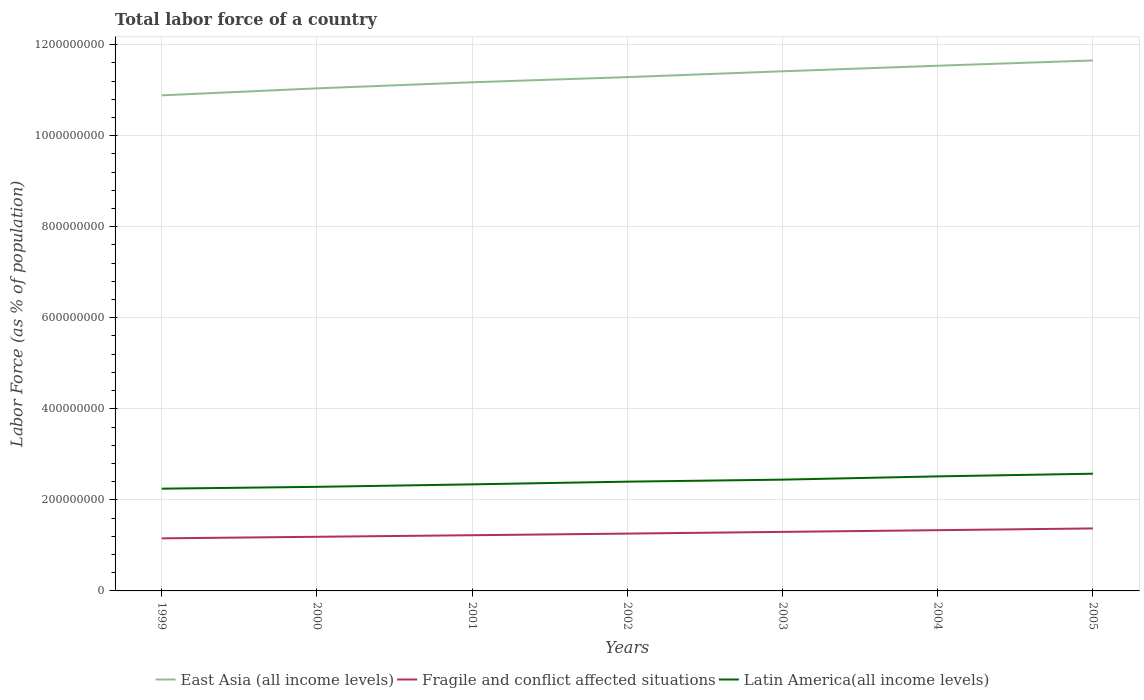Is the number of lines equal to the number of legend labels?
Give a very brief answer. Yes. Across all years, what is the maximum percentage of labor force in Latin America(all income levels)?
Offer a terse response. 2.25e+08. What is the total percentage of labor force in Fragile and conflict affected situations in the graph?
Keep it short and to the point. -3.82e+06. What is the difference between the highest and the second highest percentage of labor force in Latin America(all income levels)?
Offer a terse response. 3.29e+07. What is the difference between the highest and the lowest percentage of labor force in Fragile and conflict affected situations?
Your response must be concise. 3. How many lines are there?
Your response must be concise. 3. How many years are there in the graph?
Your answer should be very brief. 7. What is the difference between two consecutive major ticks on the Y-axis?
Give a very brief answer. 2.00e+08. Does the graph contain grids?
Offer a terse response. Yes. Where does the legend appear in the graph?
Give a very brief answer. Bottom center. How many legend labels are there?
Keep it short and to the point. 3. What is the title of the graph?
Your response must be concise. Total labor force of a country. Does "High income: nonOECD" appear as one of the legend labels in the graph?
Your answer should be very brief. No. What is the label or title of the X-axis?
Offer a very short reply. Years. What is the label or title of the Y-axis?
Give a very brief answer. Labor Force (as % of population). What is the Labor Force (as % of population) of East Asia (all income levels) in 1999?
Give a very brief answer. 1.09e+09. What is the Labor Force (as % of population) in Fragile and conflict affected situations in 1999?
Give a very brief answer. 1.15e+08. What is the Labor Force (as % of population) of Latin America(all income levels) in 1999?
Ensure brevity in your answer.  2.25e+08. What is the Labor Force (as % of population) in East Asia (all income levels) in 2000?
Provide a succinct answer. 1.10e+09. What is the Labor Force (as % of population) of Fragile and conflict affected situations in 2000?
Keep it short and to the point. 1.19e+08. What is the Labor Force (as % of population) of Latin America(all income levels) in 2000?
Offer a very short reply. 2.29e+08. What is the Labor Force (as % of population) in East Asia (all income levels) in 2001?
Offer a terse response. 1.12e+09. What is the Labor Force (as % of population) in Fragile and conflict affected situations in 2001?
Make the answer very short. 1.22e+08. What is the Labor Force (as % of population) of Latin America(all income levels) in 2001?
Make the answer very short. 2.34e+08. What is the Labor Force (as % of population) in East Asia (all income levels) in 2002?
Ensure brevity in your answer.  1.13e+09. What is the Labor Force (as % of population) of Fragile and conflict affected situations in 2002?
Provide a short and direct response. 1.26e+08. What is the Labor Force (as % of population) in Latin America(all income levels) in 2002?
Give a very brief answer. 2.40e+08. What is the Labor Force (as % of population) in East Asia (all income levels) in 2003?
Keep it short and to the point. 1.14e+09. What is the Labor Force (as % of population) of Fragile and conflict affected situations in 2003?
Provide a succinct answer. 1.30e+08. What is the Labor Force (as % of population) in Latin America(all income levels) in 2003?
Ensure brevity in your answer.  2.44e+08. What is the Labor Force (as % of population) of East Asia (all income levels) in 2004?
Provide a short and direct response. 1.15e+09. What is the Labor Force (as % of population) of Fragile and conflict affected situations in 2004?
Make the answer very short. 1.33e+08. What is the Labor Force (as % of population) in Latin America(all income levels) in 2004?
Your response must be concise. 2.52e+08. What is the Labor Force (as % of population) in East Asia (all income levels) in 2005?
Provide a succinct answer. 1.17e+09. What is the Labor Force (as % of population) of Fragile and conflict affected situations in 2005?
Make the answer very short. 1.37e+08. What is the Labor Force (as % of population) of Latin America(all income levels) in 2005?
Keep it short and to the point. 2.57e+08. Across all years, what is the maximum Labor Force (as % of population) in East Asia (all income levels)?
Give a very brief answer. 1.17e+09. Across all years, what is the maximum Labor Force (as % of population) in Fragile and conflict affected situations?
Your answer should be very brief. 1.37e+08. Across all years, what is the maximum Labor Force (as % of population) in Latin America(all income levels)?
Make the answer very short. 2.57e+08. Across all years, what is the minimum Labor Force (as % of population) of East Asia (all income levels)?
Your answer should be very brief. 1.09e+09. Across all years, what is the minimum Labor Force (as % of population) in Fragile and conflict affected situations?
Ensure brevity in your answer.  1.15e+08. Across all years, what is the minimum Labor Force (as % of population) in Latin America(all income levels)?
Your answer should be very brief. 2.25e+08. What is the total Labor Force (as % of population) in East Asia (all income levels) in the graph?
Your answer should be very brief. 7.90e+09. What is the total Labor Force (as % of population) of Fragile and conflict affected situations in the graph?
Offer a terse response. 8.83e+08. What is the total Labor Force (as % of population) in Latin America(all income levels) in the graph?
Your answer should be very brief. 1.68e+09. What is the difference between the Labor Force (as % of population) in East Asia (all income levels) in 1999 and that in 2000?
Provide a succinct answer. -1.53e+07. What is the difference between the Labor Force (as % of population) of Fragile and conflict affected situations in 1999 and that in 2000?
Offer a very short reply. -3.44e+06. What is the difference between the Labor Force (as % of population) in Latin America(all income levels) in 1999 and that in 2000?
Give a very brief answer. -4.02e+06. What is the difference between the Labor Force (as % of population) in East Asia (all income levels) in 1999 and that in 2001?
Keep it short and to the point. -2.87e+07. What is the difference between the Labor Force (as % of population) in Fragile and conflict affected situations in 1999 and that in 2001?
Offer a terse response. -6.85e+06. What is the difference between the Labor Force (as % of population) of Latin America(all income levels) in 1999 and that in 2001?
Your response must be concise. -9.49e+06. What is the difference between the Labor Force (as % of population) of East Asia (all income levels) in 1999 and that in 2002?
Give a very brief answer. -4.00e+07. What is the difference between the Labor Force (as % of population) in Fragile and conflict affected situations in 1999 and that in 2002?
Make the answer very short. -1.04e+07. What is the difference between the Labor Force (as % of population) of Latin America(all income levels) in 1999 and that in 2002?
Your answer should be very brief. -1.54e+07. What is the difference between the Labor Force (as % of population) of East Asia (all income levels) in 1999 and that in 2003?
Your answer should be very brief. -5.28e+07. What is the difference between the Labor Force (as % of population) in Fragile and conflict affected situations in 1999 and that in 2003?
Keep it short and to the point. -1.42e+07. What is the difference between the Labor Force (as % of population) of Latin America(all income levels) in 1999 and that in 2003?
Offer a very short reply. -1.99e+07. What is the difference between the Labor Force (as % of population) of East Asia (all income levels) in 1999 and that in 2004?
Give a very brief answer. -6.50e+07. What is the difference between the Labor Force (as % of population) of Fragile and conflict affected situations in 1999 and that in 2004?
Your answer should be very brief. -1.79e+07. What is the difference between the Labor Force (as % of population) in Latin America(all income levels) in 1999 and that in 2004?
Make the answer very short. -2.70e+07. What is the difference between the Labor Force (as % of population) in East Asia (all income levels) in 1999 and that in 2005?
Your answer should be very brief. -7.66e+07. What is the difference between the Labor Force (as % of population) in Fragile and conflict affected situations in 1999 and that in 2005?
Your answer should be very brief. -2.18e+07. What is the difference between the Labor Force (as % of population) of Latin America(all income levels) in 1999 and that in 2005?
Make the answer very short. -3.29e+07. What is the difference between the Labor Force (as % of population) of East Asia (all income levels) in 2000 and that in 2001?
Provide a succinct answer. -1.34e+07. What is the difference between the Labor Force (as % of population) of Fragile and conflict affected situations in 2000 and that in 2001?
Ensure brevity in your answer.  -3.41e+06. What is the difference between the Labor Force (as % of population) of Latin America(all income levels) in 2000 and that in 2001?
Ensure brevity in your answer.  -5.47e+06. What is the difference between the Labor Force (as % of population) in East Asia (all income levels) in 2000 and that in 2002?
Offer a terse response. -2.47e+07. What is the difference between the Labor Force (as % of population) in Fragile and conflict affected situations in 2000 and that in 2002?
Offer a very short reply. -7.00e+06. What is the difference between the Labor Force (as % of population) in Latin America(all income levels) in 2000 and that in 2002?
Keep it short and to the point. -1.14e+07. What is the difference between the Labor Force (as % of population) in East Asia (all income levels) in 2000 and that in 2003?
Give a very brief answer. -3.76e+07. What is the difference between the Labor Force (as % of population) in Fragile and conflict affected situations in 2000 and that in 2003?
Ensure brevity in your answer.  -1.07e+07. What is the difference between the Labor Force (as % of population) in Latin America(all income levels) in 2000 and that in 2003?
Provide a short and direct response. -1.58e+07. What is the difference between the Labor Force (as % of population) in East Asia (all income levels) in 2000 and that in 2004?
Keep it short and to the point. -4.98e+07. What is the difference between the Labor Force (as % of population) in Fragile and conflict affected situations in 2000 and that in 2004?
Provide a short and direct response. -1.45e+07. What is the difference between the Labor Force (as % of population) in Latin America(all income levels) in 2000 and that in 2004?
Offer a very short reply. -2.30e+07. What is the difference between the Labor Force (as % of population) in East Asia (all income levels) in 2000 and that in 2005?
Offer a terse response. -6.13e+07. What is the difference between the Labor Force (as % of population) of Fragile and conflict affected situations in 2000 and that in 2005?
Your response must be concise. -1.83e+07. What is the difference between the Labor Force (as % of population) of Latin America(all income levels) in 2000 and that in 2005?
Your answer should be compact. -2.89e+07. What is the difference between the Labor Force (as % of population) in East Asia (all income levels) in 2001 and that in 2002?
Your response must be concise. -1.14e+07. What is the difference between the Labor Force (as % of population) in Fragile and conflict affected situations in 2001 and that in 2002?
Your answer should be compact. -3.59e+06. What is the difference between the Labor Force (as % of population) in Latin America(all income levels) in 2001 and that in 2002?
Offer a very short reply. -5.95e+06. What is the difference between the Labor Force (as % of population) in East Asia (all income levels) in 2001 and that in 2003?
Give a very brief answer. -2.42e+07. What is the difference between the Labor Force (as % of population) in Fragile and conflict affected situations in 2001 and that in 2003?
Provide a short and direct response. -7.33e+06. What is the difference between the Labor Force (as % of population) of Latin America(all income levels) in 2001 and that in 2003?
Offer a very short reply. -1.04e+07. What is the difference between the Labor Force (as % of population) of East Asia (all income levels) in 2001 and that in 2004?
Your response must be concise. -3.64e+07. What is the difference between the Labor Force (as % of population) in Fragile and conflict affected situations in 2001 and that in 2004?
Make the answer very short. -1.11e+07. What is the difference between the Labor Force (as % of population) of Latin America(all income levels) in 2001 and that in 2004?
Provide a short and direct response. -1.76e+07. What is the difference between the Labor Force (as % of population) of East Asia (all income levels) in 2001 and that in 2005?
Your response must be concise. -4.79e+07. What is the difference between the Labor Force (as % of population) in Fragile and conflict affected situations in 2001 and that in 2005?
Provide a succinct answer. -1.49e+07. What is the difference between the Labor Force (as % of population) in Latin America(all income levels) in 2001 and that in 2005?
Your answer should be compact. -2.34e+07. What is the difference between the Labor Force (as % of population) of East Asia (all income levels) in 2002 and that in 2003?
Offer a very short reply. -1.28e+07. What is the difference between the Labor Force (as % of population) of Fragile and conflict affected situations in 2002 and that in 2003?
Give a very brief answer. -3.74e+06. What is the difference between the Labor Force (as % of population) in Latin America(all income levels) in 2002 and that in 2003?
Offer a terse response. -4.43e+06. What is the difference between the Labor Force (as % of population) of East Asia (all income levels) in 2002 and that in 2004?
Your answer should be very brief. -2.50e+07. What is the difference between the Labor Force (as % of population) in Fragile and conflict affected situations in 2002 and that in 2004?
Give a very brief answer. -7.50e+06. What is the difference between the Labor Force (as % of population) in Latin America(all income levels) in 2002 and that in 2004?
Offer a very short reply. -1.16e+07. What is the difference between the Labor Force (as % of population) of East Asia (all income levels) in 2002 and that in 2005?
Give a very brief answer. -3.66e+07. What is the difference between the Labor Force (as % of population) of Fragile and conflict affected situations in 2002 and that in 2005?
Your response must be concise. -1.13e+07. What is the difference between the Labor Force (as % of population) of Latin America(all income levels) in 2002 and that in 2005?
Make the answer very short. -1.75e+07. What is the difference between the Labor Force (as % of population) of East Asia (all income levels) in 2003 and that in 2004?
Provide a short and direct response. -1.22e+07. What is the difference between the Labor Force (as % of population) in Fragile and conflict affected situations in 2003 and that in 2004?
Your answer should be compact. -3.76e+06. What is the difference between the Labor Force (as % of population) of Latin America(all income levels) in 2003 and that in 2004?
Your answer should be compact. -7.18e+06. What is the difference between the Labor Force (as % of population) in East Asia (all income levels) in 2003 and that in 2005?
Your answer should be very brief. -2.37e+07. What is the difference between the Labor Force (as % of population) of Fragile and conflict affected situations in 2003 and that in 2005?
Your answer should be very brief. -7.58e+06. What is the difference between the Labor Force (as % of population) in Latin America(all income levels) in 2003 and that in 2005?
Your response must be concise. -1.30e+07. What is the difference between the Labor Force (as % of population) of East Asia (all income levels) in 2004 and that in 2005?
Provide a short and direct response. -1.15e+07. What is the difference between the Labor Force (as % of population) of Fragile and conflict affected situations in 2004 and that in 2005?
Your response must be concise. -3.82e+06. What is the difference between the Labor Force (as % of population) of Latin America(all income levels) in 2004 and that in 2005?
Make the answer very short. -5.86e+06. What is the difference between the Labor Force (as % of population) in East Asia (all income levels) in 1999 and the Labor Force (as % of population) in Fragile and conflict affected situations in 2000?
Provide a succinct answer. 9.70e+08. What is the difference between the Labor Force (as % of population) of East Asia (all income levels) in 1999 and the Labor Force (as % of population) of Latin America(all income levels) in 2000?
Offer a terse response. 8.60e+08. What is the difference between the Labor Force (as % of population) in Fragile and conflict affected situations in 1999 and the Labor Force (as % of population) in Latin America(all income levels) in 2000?
Your answer should be very brief. -1.13e+08. What is the difference between the Labor Force (as % of population) in East Asia (all income levels) in 1999 and the Labor Force (as % of population) in Fragile and conflict affected situations in 2001?
Keep it short and to the point. 9.66e+08. What is the difference between the Labor Force (as % of population) of East Asia (all income levels) in 1999 and the Labor Force (as % of population) of Latin America(all income levels) in 2001?
Your answer should be compact. 8.54e+08. What is the difference between the Labor Force (as % of population) of Fragile and conflict affected situations in 1999 and the Labor Force (as % of population) of Latin America(all income levels) in 2001?
Your answer should be very brief. -1.19e+08. What is the difference between the Labor Force (as % of population) of East Asia (all income levels) in 1999 and the Labor Force (as % of population) of Fragile and conflict affected situations in 2002?
Make the answer very short. 9.63e+08. What is the difference between the Labor Force (as % of population) in East Asia (all income levels) in 1999 and the Labor Force (as % of population) in Latin America(all income levels) in 2002?
Ensure brevity in your answer.  8.49e+08. What is the difference between the Labor Force (as % of population) of Fragile and conflict affected situations in 1999 and the Labor Force (as % of population) of Latin America(all income levels) in 2002?
Provide a succinct answer. -1.25e+08. What is the difference between the Labor Force (as % of population) in East Asia (all income levels) in 1999 and the Labor Force (as % of population) in Fragile and conflict affected situations in 2003?
Provide a succinct answer. 9.59e+08. What is the difference between the Labor Force (as % of population) of East Asia (all income levels) in 1999 and the Labor Force (as % of population) of Latin America(all income levels) in 2003?
Offer a very short reply. 8.44e+08. What is the difference between the Labor Force (as % of population) of Fragile and conflict affected situations in 1999 and the Labor Force (as % of population) of Latin America(all income levels) in 2003?
Ensure brevity in your answer.  -1.29e+08. What is the difference between the Labor Force (as % of population) of East Asia (all income levels) in 1999 and the Labor Force (as % of population) of Fragile and conflict affected situations in 2004?
Your answer should be very brief. 9.55e+08. What is the difference between the Labor Force (as % of population) in East Asia (all income levels) in 1999 and the Labor Force (as % of population) in Latin America(all income levels) in 2004?
Provide a short and direct response. 8.37e+08. What is the difference between the Labor Force (as % of population) of Fragile and conflict affected situations in 1999 and the Labor Force (as % of population) of Latin America(all income levels) in 2004?
Provide a short and direct response. -1.36e+08. What is the difference between the Labor Force (as % of population) in East Asia (all income levels) in 1999 and the Labor Force (as % of population) in Fragile and conflict affected situations in 2005?
Offer a very short reply. 9.51e+08. What is the difference between the Labor Force (as % of population) of East Asia (all income levels) in 1999 and the Labor Force (as % of population) of Latin America(all income levels) in 2005?
Offer a terse response. 8.31e+08. What is the difference between the Labor Force (as % of population) of Fragile and conflict affected situations in 1999 and the Labor Force (as % of population) of Latin America(all income levels) in 2005?
Ensure brevity in your answer.  -1.42e+08. What is the difference between the Labor Force (as % of population) in East Asia (all income levels) in 2000 and the Labor Force (as % of population) in Fragile and conflict affected situations in 2001?
Provide a short and direct response. 9.81e+08. What is the difference between the Labor Force (as % of population) of East Asia (all income levels) in 2000 and the Labor Force (as % of population) of Latin America(all income levels) in 2001?
Ensure brevity in your answer.  8.70e+08. What is the difference between the Labor Force (as % of population) of Fragile and conflict affected situations in 2000 and the Labor Force (as % of population) of Latin America(all income levels) in 2001?
Your response must be concise. -1.15e+08. What is the difference between the Labor Force (as % of population) of East Asia (all income levels) in 2000 and the Labor Force (as % of population) of Fragile and conflict affected situations in 2002?
Your answer should be very brief. 9.78e+08. What is the difference between the Labor Force (as % of population) in East Asia (all income levels) in 2000 and the Labor Force (as % of population) in Latin America(all income levels) in 2002?
Give a very brief answer. 8.64e+08. What is the difference between the Labor Force (as % of population) in Fragile and conflict affected situations in 2000 and the Labor Force (as % of population) in Latin America(all income levels) in 2002?
Provide a short and direct response. -1.21e+08. What is the difference between the Labor Force (as % of population) of East Asia (all income levels) in 2000 and the Labor Force (as % of population) of Fragile and conflict affected situations in 2003?
Keep it short and to the point. 9.74e+08. What is the difference between the Labor Force (as % of population) of East Asia (all income levels) in 2000 and the Labor Force (as % of population) of Latin America(all income levels) in 2003?
Offer a very short reply. 8.59e+08. What is the difference between the Labor Force (as % of population) of Fragile and conflict affected situations in 2000 and the Labor Force (as % of population) of Latin America(all income levels) in 2003?
Make the answer very short. -1.26e+08. What is the difference between the Labor Force (as % of population) in East Asia (all income levels) in 2000 and the Labor Force (as % of population) in Fragile and conflict affected situations in 2004?
Provide a succinct answer. 9.70e+08. What is the difference between the Labor Force (as % of population) in East Asia (all income levels) in 2000 and the Labor Force (as % of population) in Latin America(all income levels) in 2004?
Offer a terse response. 8.52e+08. What is the difference between the Labor Force (as % of population) in Fragile and conflict affected situations in 2000 and the Labor Force (as % of population) in Latin America(all income levels) in 2004?
Offer a terse response. -1.33e+08. What is the difference between the Labor Force (as % of population) of East Asia (all income levels) in 2000 and the Labor Force (as % of population) of Fragile and conflict affected situations in 2005?
Your answer should be very brief. 9.67e+08. What is the difference between the Labor Force (as % of population) of East Asia (all income levels) in 2000 and the Labor Force (as % of population) of Latin America(all income levels) in 2005?
Provide a succinct answer. 8.46e+08. What is the difference between the Labor Force (as % of population) of Fragile and conflict affected situations in 2000 and the Labor Force (as % of population) of Latin America(all income levels) in 2005?
Keep it short and to the point. -1.39e+08. What is the difference between the Labor Force (as % of population) of East Asia (all income levels) in 2001 and the Labor Force (as % of population) of Fragile and conflict affected situations in 2002?
Your response must be concise. 9.91e+08. What is the difference between the Labor Force (as % of population) of East Asia (all income levels) in 2001 and the Labor Force (as % of population) of Latin America(all income levels) in 2002?
Your answer should be very brief. 8.77e+08. What is the difference between the Labor Force (as % of population) of Fragile and conflict affected situations in 2001 and the Labor Force (as % of population) of Latin America(all income levels) in 2002?
Your answer should be very brief. -1.18e+08. What is the difference between the Labor Force (as % of population) in East Asia (all income levels) in 2001 and the Labor Force (as % of population) in Fragile and conflict affected situations in 2003?
Ensure brevity in your answer.  9.88e+08. What is the difference between the Labor Force (as % of population) of East Asia (all income levels) in 2001 and the Labor Force (as % of population) of Latin America(all income levels) in 2003?
Offer a very short reply. 8.73e+08. What is the difference between the Labor Force (as % of population) in Fragile and conflict affected situations in 2001 and the Labor Force (as % of population) in Latin America(all income levels) in 2003?
Offer a terse response. -1.22e+08. What is the difference between the Labor Force (as % of population) of East Asia (all income levels) in 2001 and the Labor Force (as % of population) of Fragile and conflict affected situations in 2004?
Your answer should be compact. 9.84e+08. What is the difference between the Labor Force (as % of population) in East Asia (all income levels) in 2001 and the Labor Force (as % of population) in Latin America(all income levels) in 2004?
Offer a very short reply. 8.66e+08. What is the difference between the Labor Force (as % of population) in Fragile and conflict affected situations in 2001 and the Labor Force (as % of population) in Latin America(all income levels) in 2004?
Provide a succinct answer. -1.29e+08. What is the difference between the Labor Force (as % of population) in East Asia (all income levels) in 2001 and the Labor Force (as % of population) in Fragile and conflict affected situations in 2005?
Ensure brevity in your answer.  9.80e+08. What is the difference between the Labor Force (as % of population) in East Asia (all income levels) in 2001 and the Labor Force (as % of population) in Latin America(all income levels) in 2005?
Your answer should be very brief. 8.60e+08. What is the difference between the Labor Force (as % of population) in Fragile and conflict affected situations in 2001 and the Labor Force (as % of population) in Latin America(all income levels) in 2005?
Provide a short and direct response. -1.35e+08. What is the difference between the Labor Force (as % of population) of East Asia (all income levels) in 2002 and the Labor Force (as % of population) of Fragile and conflict affected situations in 2003?
Give a very brief answer. 9.99e+08. What is the difference between the Labor Force (as % of population) of East Asia (all income levels) in 2002 and the Labor Force (as % of population) of Latin America(all income levels) in 2003?
Offer a terse response. 8.84e+08. What is the difference between the Labor Force (as % of population) of Fragile and conflict affected situations in 2002 and the Labor Force (as % of population) of Latin America(all income levels) in 2003?
Provide a succinct answer. -1.19e+08. What is the difference between the Labor Force (as % of population) of East Asia (all income levels) in 2002 and the Labor Force (as % of population) of Fragile and conflict affected situations in 2004?
Make the answer very short. 9.95e+08. What is the difference between the Labor Force (as % of population) of East Asia (all income levels) in 2002 and the Labor Force (as % of population) of Latin America(all income levels) in 2004?
Your answer should be very brief. 8.77e+08. What is the difference between the Labor Force (as % of population) of Fragile and conflict affected situations in 2002 and the Labor Force (as % of population) of Latin America(all income levels) in 2004?
Your response must be concise. -1.26e+08. What is the difference between the Labor Force (as % of population) in East Asia (all income levels) in 2002 and the Labor Force (as % of population) in Fragile and conflict affected situations in 2005?
Offer a very short reply. 9.91e+08. What is the difference between the Labor Force (as % of population) of East Asia (all income levels) in 2002 and the Labor Force (as % of population) of Latin America(all income levels) in 2005?
Offer a very short reply. 8.71e+08. What is the difference between the Labor Force (as % of population) of Fragile and conflict affected situations in 2002 and the Labor Force (as % of population) of Latin America(all income levels) in 2005?
Ensure brevity in your answer.  -1.32e+08. What is the difference between the Labor Force (as % of population) in East Asia (all income levels) in 2003 and the Labor Force (as % of population) in Fragile and conflict affected situations in 2004?
Provide a succinct answer. 1.01e+09. What is the difference between the Labor Force (as % of population) of East Asia (all income levels) in 2003 and the Labor Force (as % of population) of Latin America(all income levels) in 2004?
Your response must be concise. 8.90e+08. What is the difference between the Labor Force (as % of population) in Fragile and conflict affected situations in 2003 and the Labor Force (as % of population) in Latin America(all income levels) in 2004?
Provide a succinct answer. -1.22e+08. What is the difference between the Labor Force (as % of population) in East Asia (all income levels) in 2003 and the Labor Force (as % of population) in Fragile and conflict affected situations in 2005?
Keep it short and to the point. 1.00e+09. What is the difference between the Labor Force (as % of population) in East Asia (all income levels) in 2003 and the Labor Force (as % of population) in Latin America(all income levels) in 2005?
Provide a short and direct response. 8.84e+08. What is the difference between the Labor Force (as % of population) in Fragile and conflict affected situations in 2003 and the Labor Force (as % of population) in Latin America(all income levels) in 2005?
Your answer should be compact. -1.28e+08. What is the difference between the Labor Force (as % of population) of East Asia (all income levels) in 2004 and the Labor Force (as % of population) of Fragile and conflict affected situations in 2005?
Make the answer very short. 1.02e+09. What is the difference between the Labor Force (as % of population) in East Asia (all income levels) in 2004 and the Labor Force (as % of population) in Latin America(all income levels) in 2005?
Make the answer very short. 8.96e+08. What is the difference between the Labor Force (as % of population) of Fragile and conflict affected situations in 2004 and the Labor Force (as % of population) of Latin America(all income levels) in 2005?
Give a very brief answer. -1.24e+08. What is the average Labor Force (as % of population) of East Asia (all income levels) per year?
Offer a very short reply. 1.13e+09. What is the average Labor Force (as % of population) of Fragile and conflict affected situations per year?
Your response must be concise. 1.26e+08. What is the average Labor Force (as % of population) of Latin America(all income levels) per year?
Your response must be concise. 2.40e+08. In the year 1999, what is the difference between the Labor Force (as % of population) of East Asia (all income levels) and Labor Force (as % of population) of Fragile and conflict affected situations?
Give a very brief answer. 9.73e+08. In the year 1999, what is the difference between the Labor Force (as % of population) of East Asia (all income levels) and Labor Force (as % of population) of Latin America(all income levels)?
Your answer should be compact. 8.64e+08. In the year 1999, what is the difference between the Labor Force (as % of population) in Fragile and conflict affected situations and Labor Force (as % of population) in Latin America(all income levels)?
Your response must be concise. -1.09e+08. In the year 2000, what is the difference between the Labor Force (as % of population) of East Asia (all income levels) and Labor Force (as % of population) of Fragile and conflict affected situations?
Your answer should be very brief. 9.85e+08. In the year 2000, what is the difference between the Labor Force (as % of population) in East Asia (all income levels) and Labor Force (as % of population) in Latin America(all income levels)?
Make the answer very short. 8.75e+08. In the year 2000, what is the difference between the Labor Force (as % of population) in Fragile and conflict affected situations and Labor Force (as % of population) in Latin America(all income levels)?
Ensure brevity in your answer.  -1.10e+08. In the year 2001, what is the difference between the Labor Force (as % of population) of East Asia (all income levels) and Labor Force (as % of population) of Fragile and conflict affected situations?
Provide a succinct answer. 9.95e+08. In the year 2001, what is the difference between the Labor Force (as % of population) in East Asia (all income levels) and Labor Force (as % of population) in Latin America(all income levels)?
Keep it short and to the point. 8.83e+08. In the year 2001, what is the difference between the Labor Force (as % of population) of Fragile and conflict affected situations and Labor Force (as % of population) of Latin America(all income levels)?
Keep it short and to the point. -1.12e+08. In the year 2002, what is the difference between the Labor Force (as % of population) in East Asia (all income levels) and Labor Force (as % of population) in Fragile and conflict affected situations?
Your answer should be very brief. 1.00e+09. In the year 2002, what is the difference between the Labor Force (as % of population) in East Asia (all income levels) and Labor Force (as % of population) in Latin America(all income levels)?
Your response must be concise. 8.89e+08. In the year 2002, what is the difference between the Labor Force (as % of population) of Fragile and conflict affected situations and Labor Force (as % of population) of Latin America(all income levels)?
Make the answer very short. -1.14e+08. In the year 2003, what is the difference between the Labor Force (as % of population) of East Asia (all income levels) and Labor Force (as % of population) of Fragile and conflict affected situations?
Provide a succinct answer. 1.01e+09. In the year 2003, what is the difference between the Labor Force (as % of population) in East Asia (all income levels) and Labor Force (as % of population) in Latin America(all income levels)?
Keep it short and to the point. 8.97e+08. In the year 2003, what is the difference between the Labor Force (as % of population) in Fragile and conflict affected situations and Labor Force (as % of population) in Latin America(all income levels)?
Ensure brevity in your answer.  -1.15e+08. In the year 2004, what is the difference between the Labor Force (as % of population) in East Asia (all income levels) and Labor Force (as % of population) in Fragile and conflict affected situations?
Provide a succinct answer. 1.02e+09. In the year 2004, what is the difference between the Labor Force (as % of population) in East Asia (all income levels) and Labor Force (as % of population) in Latin America(all income levels)?
Offer a very short reply. 9.02e+08. In the year 2004, what is the difference between the Labor Force (as % of population) of Fragile and conflict affected situations and Labor Force (as % of population) of Latin America(all income levels)?
Give a very brief answer. -1.18e+08. In the year 2005, what is the difference between the Labor Force (as % of population) of East Asia (all income levels) and Labor Force (as % of population) of Fragile and conflict affected situations?
Ensure brevity in your answer.  1.03e+09. In the year 2005, what is the difference between the Labor Force (as % of population) of East Asia (all income levels) and Labor Force (as % of population) of Latin America(all income levels)?
Ensure brevity in your answer.  9.08e+08. In the year 2005, what is the difference between the Labor Force (as % of population) of Fragile and conflict affected situations and Labor Force (as % of population) of Latin America(all income levels)?
Provide a short and direct response. -1.20e+08. What is the ratio of the Labor Force (as % of population) of East Asia (all income levels) in 1999 to that in 2000?
Your answer should be compact. 0.99. What is the ratio of the Labor Force (as % of population) in Fragile and conflict affected situations in 1999 to that in 2000?
Your answer should be compact. 0.97. What is the ratio of the Labor Force (as % of population) of Latin America(all income levels) in 1999 to that in 2000?
Ensure brevity in your answer.  0.98. What is the ratio of the Labor Force (as % of population) in East Asia (all income levels) in 1999 to that in 2001?
Give a very brief answer. 0.97. What is the ratio of the Labor Force (as % of population) of Fragile and conflict affected situations in 1999 to that in 2001?
Keep it short and to the point. 0.94. What is the ratio of the Labor Force (as % of population) in Latin America(all income levels) in 1999 to that in 2001?
Ensure brevity in your answer.  0.96. What is the ratio of the Labor Force (as % of population) of East Asia (all income levels) in 1999 to that in 2002?
Make the answer very short. 0.96. What is the ratio of the Labor Force (as % of population) of Fragile and conflict affected situations in 1999 to that in 2002?
Keep it short and to the point. 0.92. What is the ratio of the Labor Force (as % of population) in Latin America(all income levels) in 1999 to that in 2002?
Ensure brevity in your answer.  0.94. What is the ratio of the Labor Force (as % of population) in East Asia (all income levels) in 1999 to that in 2003?
Offer a terse response. 0.95. What is the ratio of the Labor Force (as % of population) in Fragile and conflict affected situations in 1999 to that in 2003?
Your response must be concise. 0.89. What is the ratio of the Labor Force (as % of population) of Latin America(all income levels) in 1999 to that in 2003?
Give a very brief answer. 0.92. What is the ratio of the Labor Force (as % of population) of East Asia (all income levels) in 1999 to that in 2004?
Your answer should be compact. 0.94. What is the ratio of the Labor Force (as % of population) in Fragile and conflict affected situations in 1999 to that in 2004?
Ensure brevity in your answer.  0.87. What is the ratio of the Labor Force (as % of population) in Latin America(all income levels) in 1999 to that in 2004?
Your answer should be very brief. 0.89. What is the ratio of the Labor Force (as % of population) of East Asia (all income levels) in 1999 to that in 2005?
Offer a very short reply. 0.93. What is the ratio of the Labor Force (as % of population) of Fragile and conflict affected situations in 1999 to that in 2005?
Ensure brevity in your answer.  0.84. What is the ratio of the Labor Force (as % of population) of Latin America(all income levels) in 1999 to that in 2005?
Provide a short and direct response. 0.87. What is the ratio of the Labor Force (as % of population) in East Asia (all income levels) in 2000 to that in 2001?
Your response must be concise. 0.99. What is the ratio of the Labor Force (as % of population) of Fragile and conflict affected situations in 2000 to that in 2001?
Provide a short and direct response. 0.97. What is the ratio of the Labor Force (as % of population) of Latin America(all income levels) in 2000 to that in 2001?
Make the answer very short. 0.98. What is the ratio of the Labor Force (as % of population) in East Asia (all income levels) in 2000 to that in 2002?
Offer a very short reply. 0.98. What is the ratio of the Labor Force (as % of population) of Latin America(all income levels) in 2000 to that in 2002?
Provide a short and direct response. 0.95. What is the ratio of the Labor Force (as % of population) in East Asia (all income levels) in 2000 to that in 2003?
Your answer should be very brief. 0.97. What is the ratio of the Labor Force (as % of population) of Fragile and conflict affected situations in 2000 to that in 2003?
Offer a very short reply. 0.92. What is the ratio of the Labor Force (as % of population) of Latin America(all income levels) in 2000 to that in 2003?
Provide a short and direct response. 0.94. What is the ratio of the Labor Force (as % of population) in East Asia (all income levels) in 2000 to that in 2004?
Keep it short and to the point. 0.96. What is the ratio of the Labor Force (as % of population) of Fragile and conflict affected situations in 2000 to that in 2004?
Your answer should be very brief. 0.89. What is the ratio of the Labor Force (as % of population) in Latin America(all income levels) in 2000 to that in 2004?
Offer a very short reply. 0.91. What is the ratio of the Labor Force (as % of population) in Fragile and conflict affected situations in 2000 to that in 2005?
Ensure brevity in your answer.  0.87. What is the ratio of the Labor Force (as % of population) of Latin America(all income levels) in 2000 to that in 2005?
Your response must be concise. 0.89. What is the ratio of the Labor Force (as % of population) of East Asia (all income levels) in 2001 to that in 2002?
Ensure brevity in your answer.  0.99. What is the ratio of the Labor Force (as % of population) of Fragile and conflict affected situations in 2001 to that in 2002?
Your answer should be compact. 0.97. What is the ratio of the Labor Force (as % of population) in Latin America(all income levels) in 2001 to that in 2002?
Offer a terse response. 0.98. What is the ratio of the Labor Force (as % of population) in East Asia (all income levels) in 2001 to that in 2003?
Offer a very short reply. 0.98. What is the ratio of the Labor Force (as % of population) in Fragile and conflict affected situations in 2001 to that in 2003?
Offer a very short reply. 0.94. What is the ratio of the Labor Force (as % of population) in Latin America(all income levels) in 2001 to that in 2003?
Keep it short and to the point. 0.96. What is the ratio of the Labor Force (as % of population) in East Asia (all income levels) in 2001 to that in 2004?
Your response must be concise. 0.97. What is the ratio of the Labor Force (as % of population) in Fragile and conflict affected situations in 2001 to that in 2004?
Your answer should be compact. 0.92. What is the ratio of the Labor Force (as % of population) of Latin America(all income levels) in 2001 to that in 2004?
Provide a short and direct response. 0.93. What is the ratio of the Labor Force (as % of population) of East Asia (all income levels) in 2001 to that in 2005?
Ensure brevity in your answer.  0.96. What is the ratio of the Labor Force (as % of population) in Fragile and conflict affected situations in 2001 to that in 2005?
Your answer should be very brief. 0.89. What is the ratio of the Labor Force (as % of population) of Fragile and conflict affected situations in 2002 to that in 2003?
Ensure brevity in your answer.  0.97. What is the ratio of the Labor Force (as % of population) in Latin America(all income levels) in 2002 to that in 2003?
Offer a very short reply. 0.98. What is the ratio of the Labor Force (as % of population) of East Asia (all income levels) in 2002 to that in 2004?
Offer a very short reply. 0.98. What is the ratio of the Labor Force (as % of population) in Fragile and conflict affected situations in 2002 to that in 2004?
Ensure brevity in your answer.  0.94. What is the ratio of the Labor Force (as % of population) of Latin America(all income levels) in 2002 to that in 2004?
Make the answer very short. 0.95. What is the ratio of the Labor Force (as % of population) in East Asia (all income levels) in 2002 to that in 2005?
Provide a short and direct response. 0.97. What is the ratio of the Labor Force (as % of population) in Fragile and conflict affected situations in 2002 to that in 2005?
Your answer should be very brief. 0.92. What is the ratio of the Labor Force (as % of population) of Latin America(all income levels) in 2002 to that in 2005?
Offer a very short reply. 0.93. What is the ratio of the Labor Force (as % of population) of Fragile and conflict affected situations in 2003 to that in 2004?
Ensure brevity in your answer.  0.97. What is the ratio of the Labor Force (as % of population) in Latin America(all income levels) in 2003 to that in 2004?
Make the answer very short. 0.97. What is the ratio of the Labor Force (as % of population) in East Asia (all income levels) in 2003 to that in 2005?
Your response must be concise. 0.98. What is the ratio of the Labor Force (as % of population) in Fragile and conflict affected situations in 2003 to that in 2005?
Provide a succinct answer. 0.94. What is the ratio of the Labor Force (as % of population) of Latin America(all income levels) in 2003 to that in 2005?
Make the answer very short. 0.95. What is the ratio of the Labor Force (as % of population) of Fragile and conflict affected situations in 2004 to that in 2005?
Offer a very short reply. 0.97. What is the ratio of the Labor Force (as % of population) of Latin America(all income levels) in 2004 to that in 2005?
Make the answer very short. 0.98. What is the difference between the highest and the second highest Labor Force (as % of population) of East Asia (all income levels)?
Your answer should be very brief. 1.15e+07. What is the difference between the highest and the second highest Labor Force (as % of population) in Fragile and conflict affected situations?
Your answer should be compact. 3.82e+06. What is the difference between the highest and the second highest Labor Force (as % of population) in Latin America(all income levels)?
Keep it short and to the point. 5.86e+06. What is the difference between the highest and the lowest Labor Force (as % of population) of East Asia (all income levels)?
Provide a short and direct response. 7.66e+07. What is the difference between the highest and the lowest Labor Force (as % of population) of Fragile and conflict affected situations?
Provide a short and direct response. 2.18e+07. What is the difference between the highest and the lowest Labor Force (as % of population) of Latin America(all income levels)?
Your answer should be compact. 3.29e+07. 